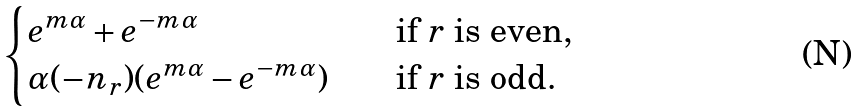<formula> <loc_0><loc_0><loc_500><loc_500>\begin{cases} e ^ { m \alpha } + e ^ { - m \alpha } & \quad \text {if $r$ is even} , \\ \alpha ( - n _ { r } ) ( e ^ { m \alpha } - e ^ { - m \alpha } ) & \quad \text {if $r$ is odd.} \end{cases}</formula> 